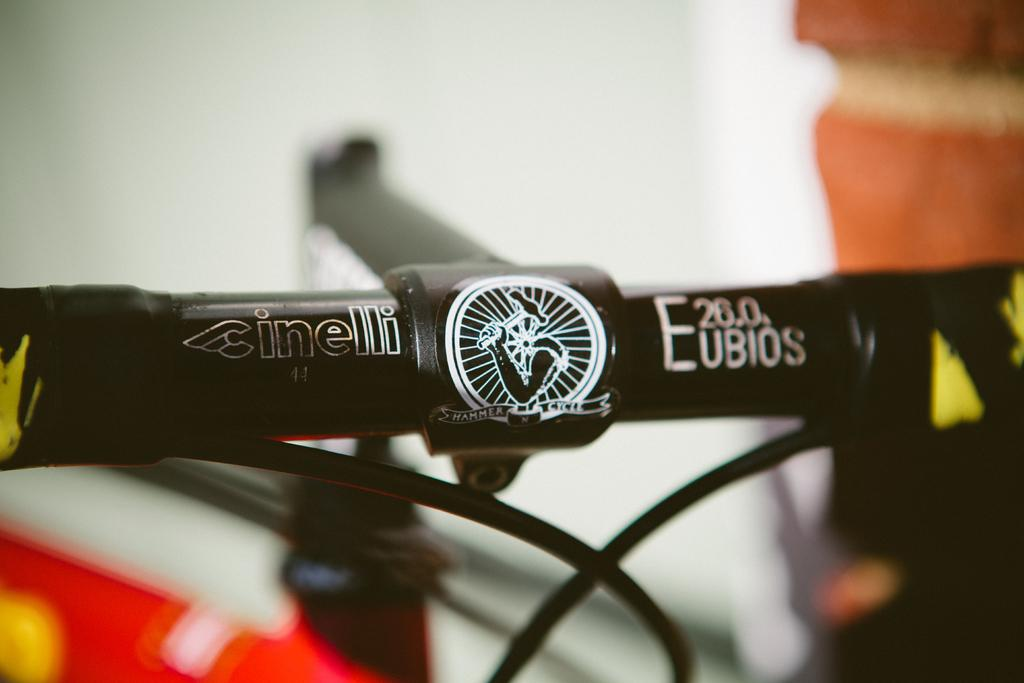What is the main object in the image? There is a rod in the image. What is written on the rod? There is writing on the rod. What else can be seen in the image besides the rod? There are wires in the image. What is the color of the background in the image? The background of the image is white. What type of throat soothing remedy is depicted in the image? There is no throat or throat soothing remedy present in the image. Can you describe the flavor of the fowl in the image? There is no fowl present in the image, so it is not possible to describe its flavor. 